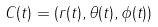Convert formula to latex. <formula><loc_0><loc_0><loc_500><loc_500>C ( t ) = ( r ( t ) , \theta ( t ) , \phi ( t ) )</formula> 